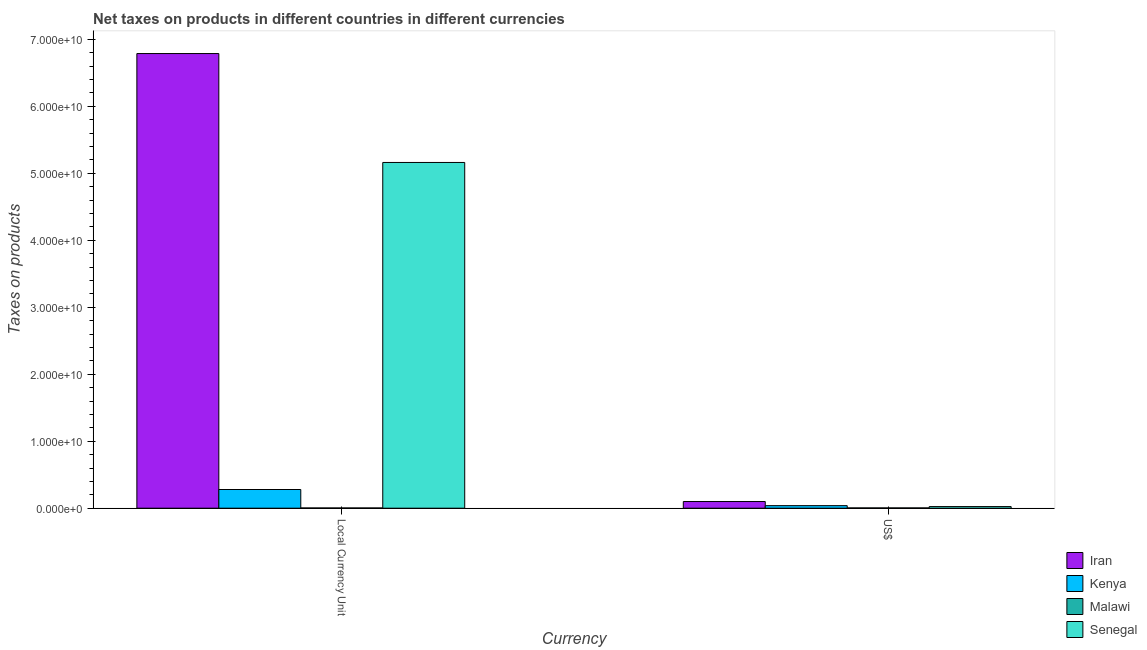How many groups of bars are there?
Keep it short and to the point. 2. Are the number of bars per tick equal to the number of legend labels?
Keep it short and to the point. Yes. Are the number of bars on each tick of the X-axis equal?
Your answer should be very brief. Yes. How many bars are there on the 2nd tick from the right?
Your answer should be compact. 4. What is the label of the 2nd group of bars from the left?
Your answer should be very brief. US$. What is the net taxes in us$ in Malawi?
Offer a terse response. 4.05e+07. Across all countries, what is the maximum net taxes in constant 2005 us$?
Provide a short and direct response. 6.79e+1. Across all countries, what is the minimum net taxes in us$?
Ensure brevity in your answer.  4.05e+07. In which country was the net taxes in us$ maximum?
Provide a short and direct response. Iran. In which country was the net taxes in us$ minimum?
Your answer should be compact. Malawi. What is the total net taxes in constant 2005 us$ in the graph?
Ensure brevity in your answer.  1.22e+11. What is the difference between the net taxes in us$ in Kenya and that in Senegal?
Provide a succinct answer. 1.39e+08. What is the difference between the net taxes in us$ in Malawi and the net taxes in constant 2005 us$ in Kenya?
Provide a short and direct response. -2.75e+09. What is the average net taxes in us$ per country?
Offer a terse response. 4.14e+08. What is the difference between the net taxes in constant 2005 us$ and net taxes in us$ in Kenya?
Your response must be concise. 2.41e+09. In how many countries, is the net taxes in us$ greater than 56000000000 units?
Ensure brevity in your answer.  0. What is the ratio of the net taxes in constant 2005 us$ in Malawi to that in Kenya?
Offer a terse response. 0.01. What does the 2nd bar from the left in US$ represents?
Give a very brief answer. Kenya. What does the 2nd bar from the right in Local Currency Unit represents?
Your response must be concise. Malawi. Are all the bars in the graph horizontal?
Your response must be concise. No. How many countries are there in the graph?
Keep it short and to the point. 4. Are the values on the major ticks of Y-axis written in scientific E-notation?
Keep it short and to the point. Yes. Does the graph contain any zero values?
Provide a short and direct response. No. Where does the legend appear in the graph?
Keep it short and to the point. Bottom right. What is the title of the graph?
Make the answer very short. Net taxes on products in different countries in different currencies. What is the label or title of the X-axis?
Make the answer very short. Currency. What is the label or title of the Y-axis?
Offer a terse response. Taxes on products. What is the Taxes on products of Iran in Local Currency Unit?
Give a very brief answer. 6.79e+1. What is the Taxes on products of Kenya in Local Currency Unit?
Your answer should be compact. 2.79e+09. What is the Taxes on products of Malawi in Local Currency Unit?
Keep it short and to the point. 3.50e+07. What is the Taxes on products in Senegal in Local Currency Unit?
Make the answer very short. 5.16e+1. What is the Taxes on products in Iran in US$?
Provide a short and direct response. 9.96e+08. What is the Taxes on products of Kenya in US$?
Provide a short and direct response. 3.80e+08. What is the Taxes on products of Malawi in US$?
Your answer should be very brief. 4.05e+07. What is the Taxes on products of Senegal in US$?
Give a very brief answer. 2.41e+08. Across all Currency, what is the maximum Taxes on products in Iran?
Your response must be concise. 6.79e+1. Across all Currency, what is the maximum Taxes on products in Kenya?
Your response must be concise. 2.79e+09. Across all Currency, what is the maximum Taxes on products in Malawi?
Keep it short and to the point. 4.05e+07. Across all Currency, what is the maximum Taxes on products of Senegal?
Offer a terse response. 5.16e+1. Across all Currency, what is the minimum Taxes on products of Iran?
Offer a very short reply. 9.96e+08. Across all Currency, what is the minimum Taxes on products of Kenya?
Ensure brevity in your answer.  3.80e+08. Across all Currency, what is the minimum Taxes on products of Malawi?
Offer a terse response. 3.50e+07. Across all Currency, what is the minimum Taxes on products in Senegal?
Keep it short and to the point. 2.41e+08. What is the total Taxes on products of Iran in the graph?
Make the answer very short. 6.89e+1. What is the total Taxes on products in Kenya in the graph?
Offer a terse response. 3.17e+09. What is the total Taxes on products in Malawi in the graph?
Offer a terse response. 7.55e+07. What is the total Taxes on products of Senegal in the graph?
Ensure brevity in your answer.  5.19e+1. What is the difference between the Taxes on products in Iran in Local Currency Unit and that in US$?
Ensure brevity in your answer.  6.69e+1. What is the difference between the Taxes on products in Kenya in Local Currency Unit and that in US$?
Make the answer very short. 2.41e+09. What is the difference between the Taxes on products of Malawi in Local Currency Unit and that in US$?
Provide a short and direct response. -5.52e+06. What is the difference between the Taxes on products of Senegal in Local Currency Unit and that in US$?
Offer a terse response. 5.14e+1. What is the difference between the Taxes on products of Iran in Local Currency Unit and the Taxes on products of Kenya in US$?
Your response must be concise. 6.75e+1. What is the difference between the Taxes on products of Iran in Local Currency Unit and the Taxes on products of Malawi in US$?
Offer a very short reply. 6.78e+1. What is the difference between the Taxes on products of Iran in Local Currency Unit and the Taxes on products of Senegal in US$?
Provide a succinct answer. 6.76e+1. What is the difference between the Taxes on products of Kenya in Local Currency Unit and the Taxes on products of Malawi in US$?
Ensure brevity in your answer.  2.75e+09. What is the difference between the Taxes on products of Kenya in Local Currency Unit and the Taxes on products of Senegal in US$?
Offer a very short reply. 2.55e+09. What is the difference between the Taxes on products in Malawi in Local Currency Unit and the Taxes on products in Senegal in US$?
Offer a terse response. -2.06e+08. What is the average Taxes on products of Iran per Currency?
Make the answer very short. 3.44e+1. What is the average Taxes on products in Kenya per Currency?
Make the answer very short. 1.58e+09. What is the average Taxes on products of Malawi per Currency?
Offer a terse response. 3.78e+07. What is the average Taxes on products of Senegal per Currency?
Provide a succinct answer. 2.59e+1. What is the difference between the Taxes on products of Iran and Taxes on products of Kenya in Local Currency Unit?
Give a very brief answer. 6.51e+1. What is the difference between the Taxes on products in Iran and Taxes on products in Malawi in Local Currency Unit?
Give a very brief answer. 6.78e+1. What is the difference between the Taxes on products in Iran and Taxes on products in Senegal in Local Currency Unit?
Keep it short and to the point. 1.63e+1. What is the difference between the Taxes on products of Kenya and Taxes on products of Malawi in Local Currency Unit?
Keep it short and to the point. 2.76e+09. What is the difference between the Taxes on products of Kenya and Taxes on products of Senegal in Local Currency Unit?
Ensure brevity in your answer.  -4.88e+1. What is the difference between the Taxes on products of Malawi and Taxes on products of Senegal in Local Currency Unit?
Ensure brevity in your answer.  -5.16e+1. What is the difference between the Taxes on products of Iran and Taxes on products of Kenya in US$?
Provide a short and direct response. 6.16e+08. What is the difference between the Taxes on products of Iran and Taxes on products of Malawi in US$?
Provide a succinct answer. 9.55e+08. What is the difference between the Taxes on products of Iran and Taxes on products of Senegal in US$?
Your answer should be compact. 7.55e+08. What is the difference between the Taxes on products in Kenya and Taxes on products in Malawi in US$?
Give a very brief answer. 3.39e+08. What is the difference between the Taxes on products of Kenya and Taxes on products of Senegal in US$?
Offer a terse response. 1.39e+08. What is the difference between the Taxes on products in Malawi and Taxes on products in Senegal in US$?
Offer a terse response. -2.00e+08. What is the ratio of the Taxes on products in Iran in Local Currency Unit to that in US$?
Provide a succinct answer. 68.17. What is the ratio of the Taxes on products in Kenya in Local Currency Unit to that in US$?
Your answer should be very brief. 7.34. What is the ratio of the Taxes on products of Malawi in Local Currency Unit to that in US$?
Provide a short and direct response. 0.86. What is the ratio of the Taxes on products in Senegal in Local Currency Unit to that in US$?
Ensure brevity in your answer.  214.31. What is the difference between the highest and the second highest Taxes on products in Iran?
Keep it short and to the point. 6.69e+1. What is the difference between the highest and the second highest Taxes on products of Kenya?
Your response must be concise. 2.41e+09. What is the difference between the highest and the second highest Taxes on products in Malawi?
Your answer should be compact. 5.52e+06. What is the difference between the highest and the second highest Taxes on products in Senegal?
Your answer should be very brief. 5.14e+1. What is the difference between the highest and the lowest Taxes on products in Iran?
Offer a very short reply. 6.69e+1. What is the difference between the highest and the lowest Taxes on products of Kenya?
Ensure brevity in your answer.  2.41e+09. What is the difference between the highest and the lowest Taxes on products of Malawi?
Your answer should be very brief. 5.52e+06. What is the difference between the highest and the lowest Taxes on products of Senegal?
Provide a short and direct response. 5.14e+1. 